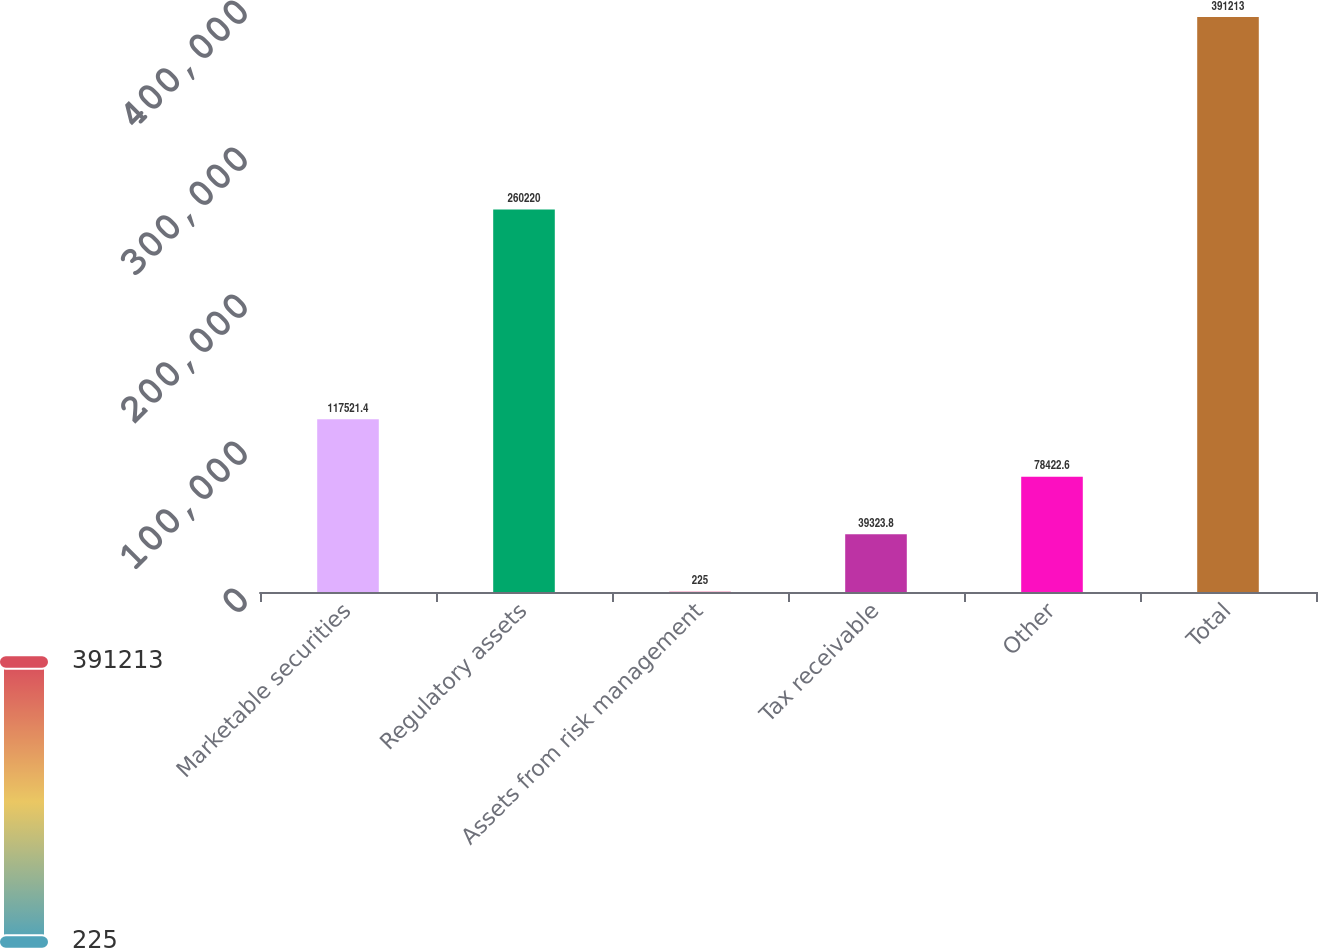<chart> <loc_0><loc_0><loc_500><loc_500><bar_chart><fcel>Marketable securities<fcel>Regulatory assets<fcel>Assets from risk management<fcel>Tax receivable<fcel>Other<fcel>Total<nl><fcel>117521<fcel>260220<fcel>225<fcel>39323.8<fcel>78422.6<fcel>391213<nl></chart> 